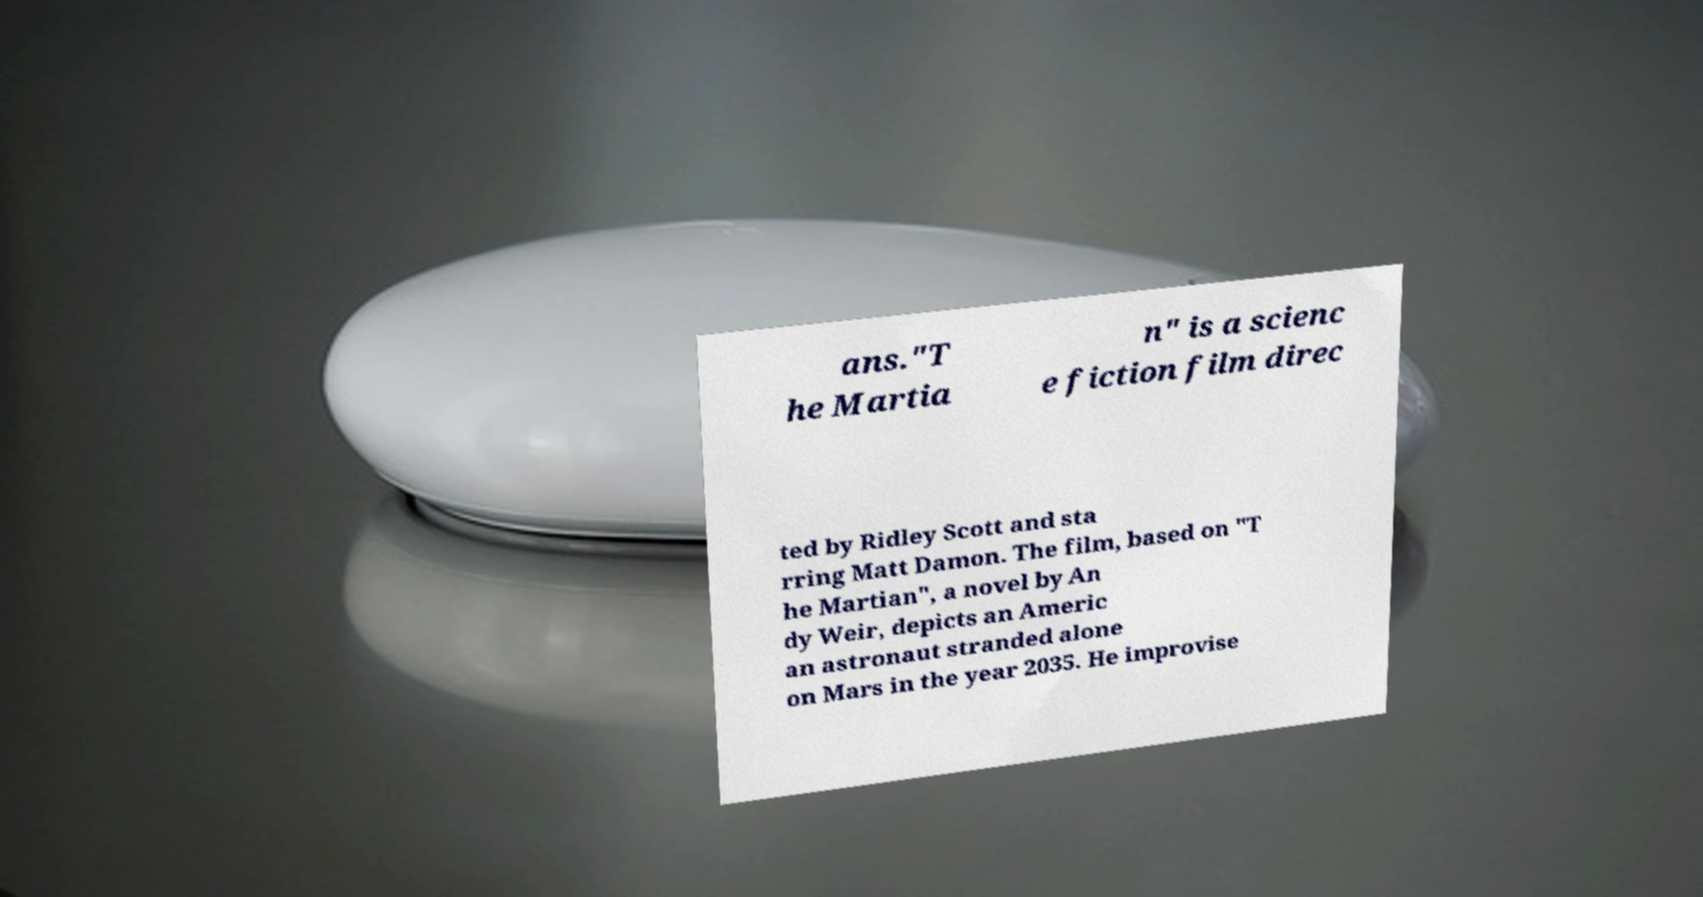Can you read and provide the text displayed in the image?This photo seems to have some interesting text. Can you extract and type it out for me? ans."T he Martia n" is a scienc e fiction film direc ted by Ridley Scott and sta rring Matt Damon. The film, based on "T he Martian", a novel by An dy Weir, depicts an Americ an astronaut stranded alone on Mars in the year 2035. He improvise 